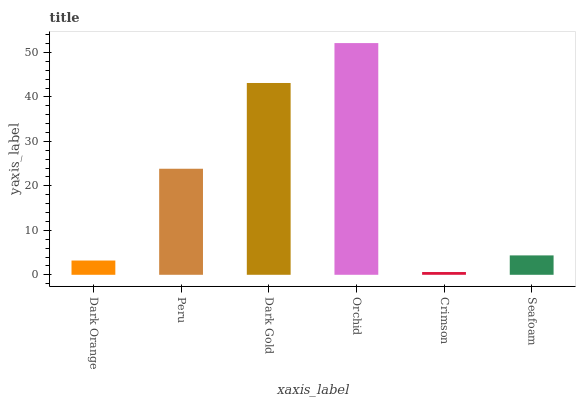Is Crimson the minimum?
Answer yes or no. Yes. Is Orchid the maximum?
Answer yes or no. Yes. Is Peru the minimum?
Answer yes or no. No. Is Peru the maximum?
Answer yes or no. No. Is Peru greater than Dark Orange?
Answer yes or no. Yes. Is Dark Orange less than Peru?
Answer yes or no. Yes. Is Dark Orange greater than Peru?
Answer yes or no. No. Is Peru less than Dark Orange?
Answer yes or no. No. Is Peru the high median?
Answer yes or no. Yes. Is Seafoam the low median?
Answer yes or no. Yes. Is Crimson the high median?
Answer yes or no. No. Is Peru the low median?
Answer yes or no. No. 